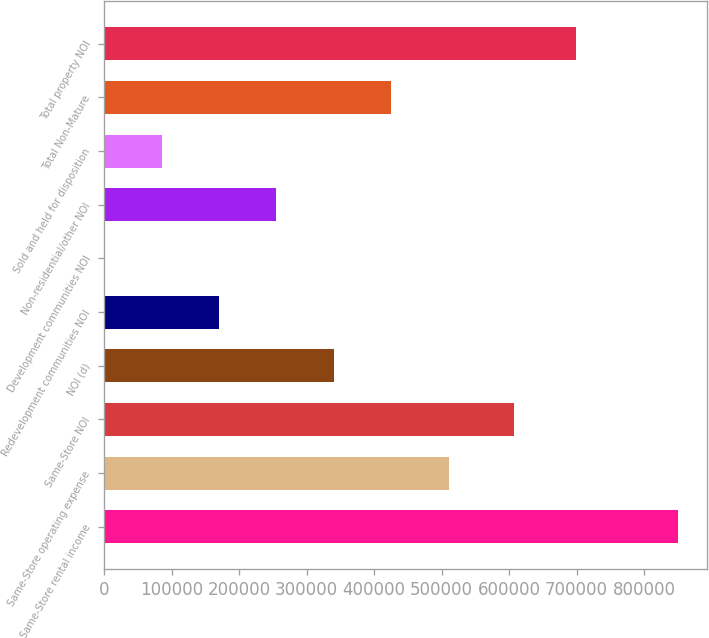Convert chart. <chart><loc_0><loc_0><loc_500><loc_500><bar_chart><fcel>Same-Store rental income<fcel>Same-Store operating expense<fcel>Same-Store NOI<fcel>NOI (d)<fcel>Redevelopment communities NOI<fcel>Development communities NOI<fcel>Non-residential/other NOI<fcel>Sold and held for disposition<fcel>Total Non-Mature<fcel>Total property NOI<nl><fcel>850065<fcel>510157<fcel>607543<fcel>340203<fcel>170249<fcel>295<fcel>255226<fcel>85272<fcel>425180<fcel>698503<nl></chart> 